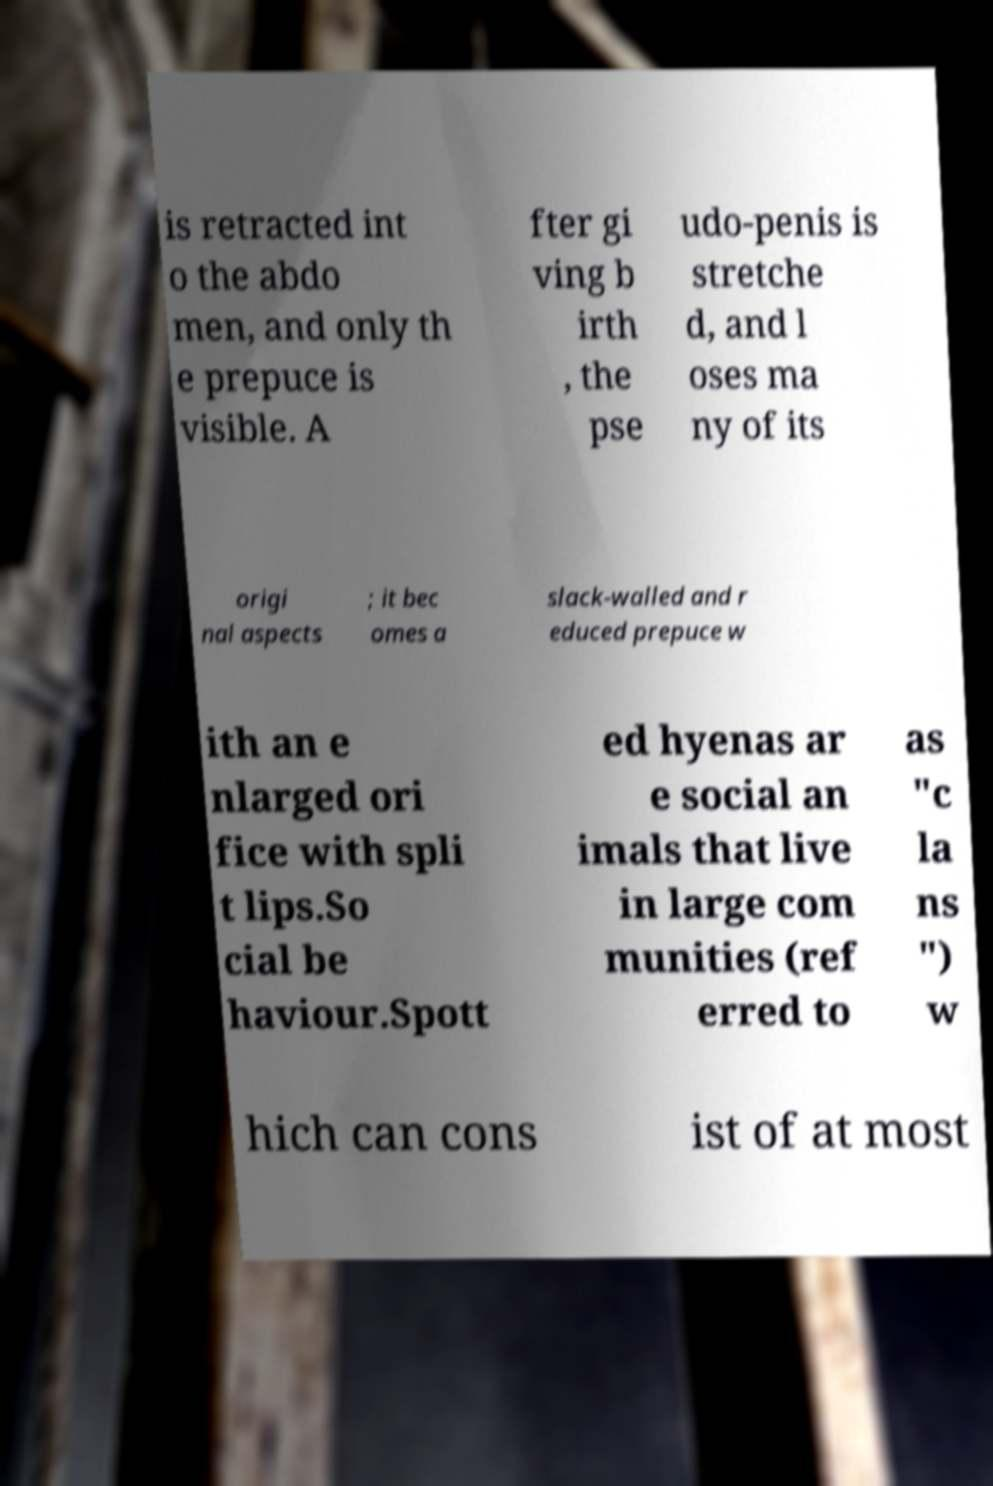Can you read and provide the text displayed in the image?This photo seems to have some interesting text. Can you extract and type it out for me? is retracted int o the abdo men, and only th e prepuce is visible. A fter gi ving b irth , the pse udo-penis is stretche d, and l oses ma ny of its origi nal aspects ; it bec omes a slack-walled and r educed prepuce w ith an e nlarged ori fice with spli t lips.So cial be haviour.Spott ed hyenas ar e social an imals that live in large com munities (ref erred to as "c la ns ") w hich can cons ist of at most 